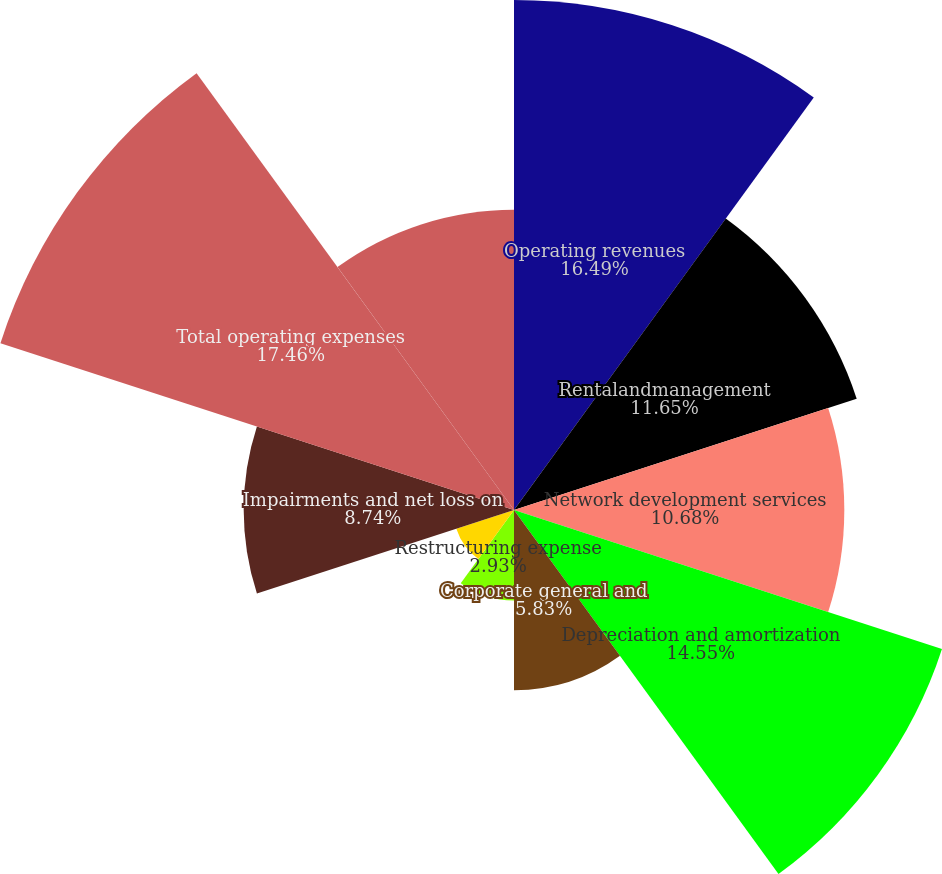<chart> <loc_0><loc_0><loc_500><loc_500><pie_chart><fcel>Operating revenues<fcel>Rentalandmanagement<fcel>Network development services<fcel>Depreciation and amortization<fcel>Corporate general and<fcel>Restructuring expense<fcel>Developmentexpense<fcel>Impairments and net loss on<fcel>Total operating expenses<fcel>Operating loss from continuing<nl><fcel>16.49%<fcel>11.65%<fcel>10.68%<fcel>14.55%<fcel>5.83%<fcel>2.93%<fcel>1.96%<fcel>8.74%<fcel>17.46%<fcel>9.71%<nl></chart> 